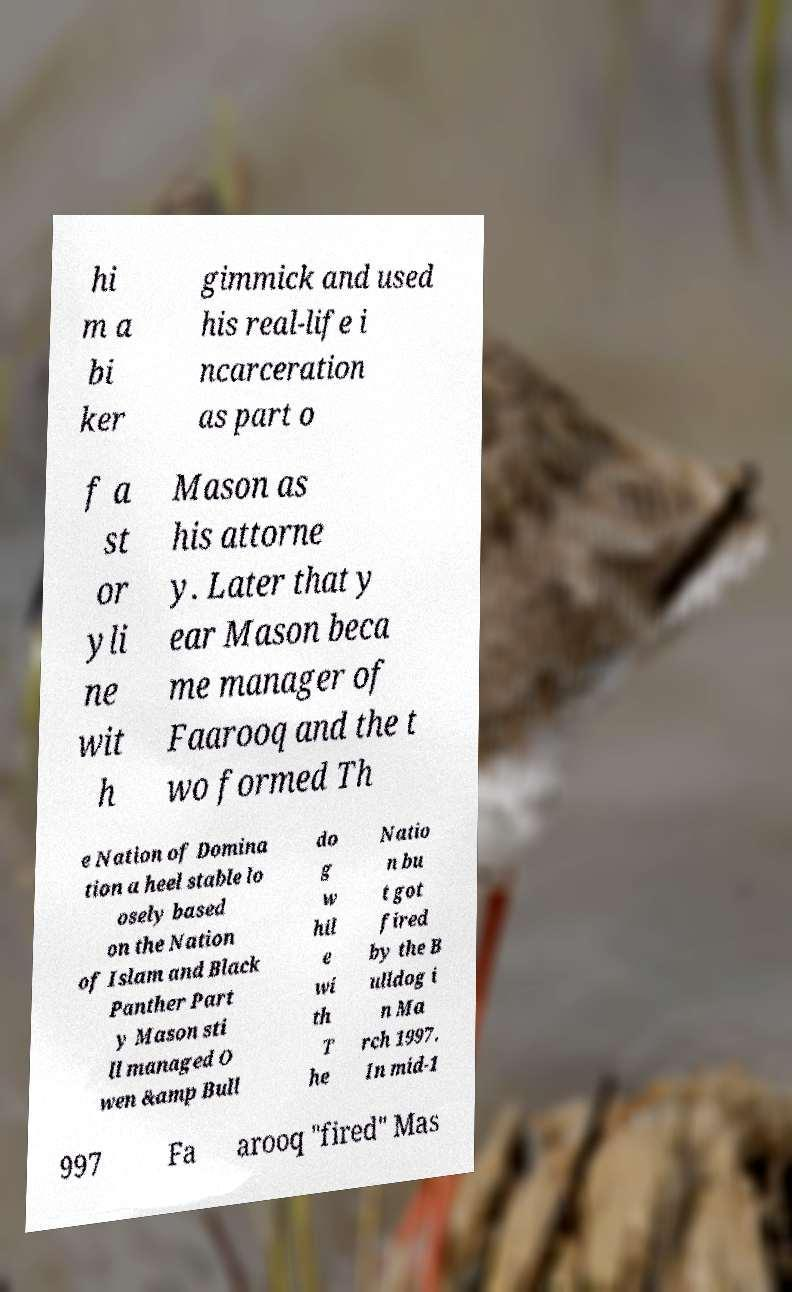I need the written content from this picture converted into text. Can you do that? hi m a bi ker gimmick and used his real-life i ncarceration as part o f a st or yli ne wit h Mason as his attorne y. Later that y ear Mason beca me manager of Faarooq and the t wo formed Th e Nation of Domina tion a heel stable lo osely based on the Nation of Islam and Black Panther Part y Mason sti ll managed O wen &amp Bull do g w hil e wi th T he Natio n bu t got fired by the B ulldog i n Ma rch 1997. In mid-1 997 Fa arooq "fired" Mas 